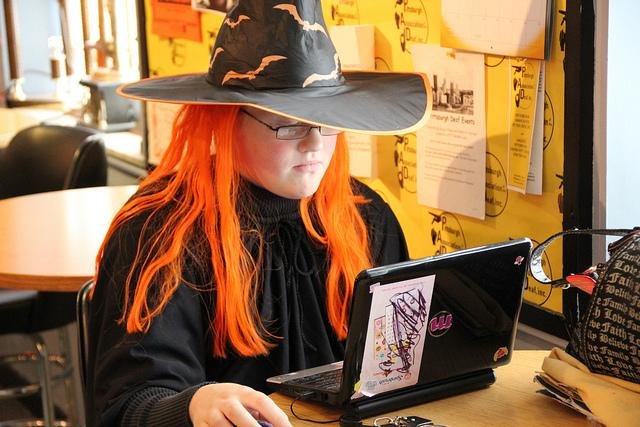What hat does the woman have on? Please explain your reasoning. witch hat. The hat is a witch's. 